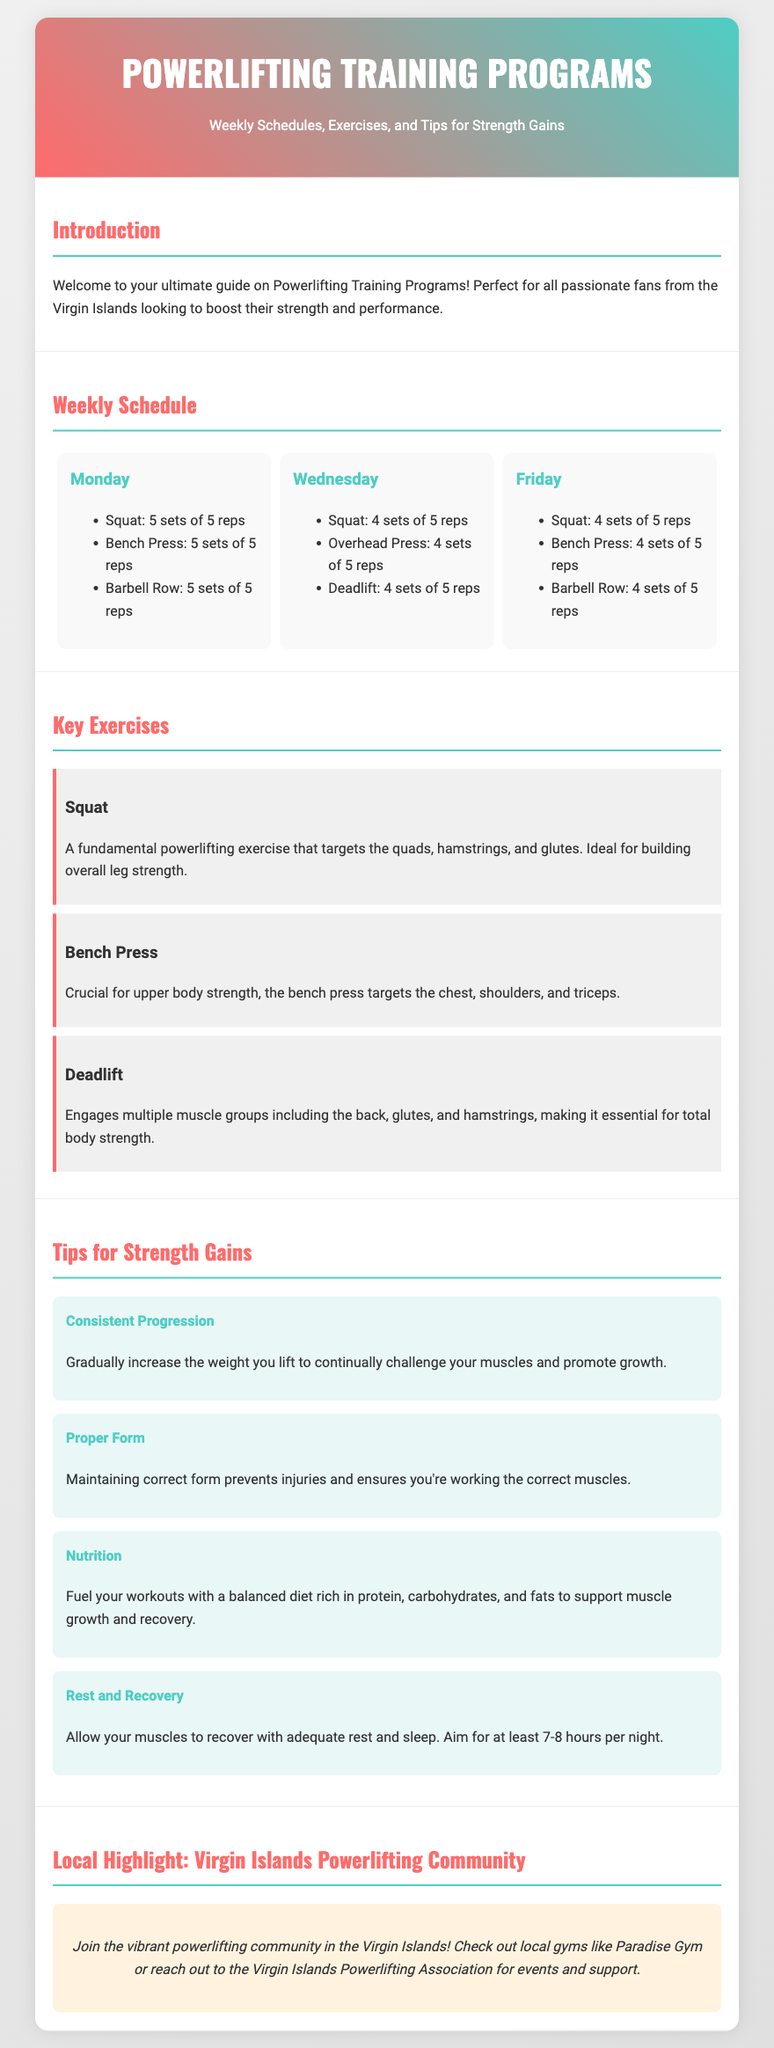What is the title of the document? The title is prominently displayed in the header of the flyer, indicating the main focus of the content.
Answer: Powerlifting Training Programs How many training days are listed in the weekly schedule? The weekly schedule includes training sessions outlined for three specific days of the week.
Answer: 3 days Which exercise is intended for upper body strength? This exercise targets specific muscles in the upper body, as indicated in the key exercises section.
Answer: Bench Press What is the focus of the tip regarding progression? This tip emphasizes the importance of progressively challenging the muscles for strength gains.
Answer: Consistent Progression What local gyms are mentioned in the document? The document highlights specific gyms in the Virgin Islands that support the powerlifting community.
Answer: Paradise Gym Which exercise works multiple muscle groups including the back? This exercise is essential for total body strength and engages several muscle groups.
Answer: Deadlift What should be included in a balanced diet for powerlifting? The document specifies the types of nutrients necessary to support muscle growth and recovery for powerlifters.
Answer: Protein, carbohydrates, and fats How many sets are recommended for squats on Monday? The weekly schedule details the number of sets for this particular exercise on the designated training day.
Answer: 5 sets What community support is suggested for powerlifters in the Virgin Islands? The document encourages engagement with local organizations to enhance the experience of those involved in powerlifting.
Answer: Virgin Islands Powerlifting Association 